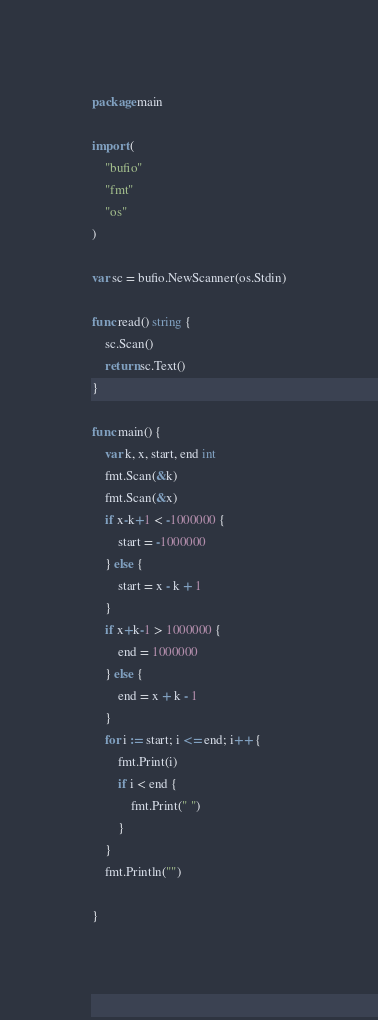<code> <loc_0><loc_0><loc_500><loc_500><_Go_>package main

import (
	"bufio"
	"fmt"
	"os"
)

var sc = bufio.NewScanner(os.Stdin)

func read() string {
	sc.Scan()
	return sc.Text()
}

func main() {
	var k, x, start, end int
	fmt.Scan(&k)
	fmt.Scan(&x)
	if x-k+1 < -1000000 {
		start = -1000000
	} else {
		start = x - k + 1
	}
	if x+k-1 > 1000000 {
		end = 1000000
	} else {
		end = x + k - 1
	}
	for i := start; i <= end; i++ {
		fmt.Print(i)
		if i < end {
			fmt.Print(" ")
		}
	}
	fmt.Println("")

}
</code> 